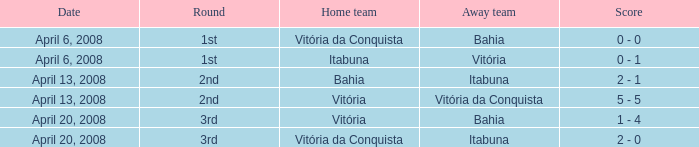Would you be able to parse every entry in this table? {'header': ['Date', 'Round', 'Home team', 'Away team', 'Score'], 'rows': [['April 6, 2008', '1st', 'Vitória da Conquista', 'Bahia', '0 - 0'], ['April 6, 2008', '1st', 'Itabuna', 'Vitória', '0 - 1'], ['April 13, 2008', '2nd', 'Bahia', 'Itabuna', '2 - 1'], ['April 13, 2008', '2nd', 'Vitória', 'Vitória da Conquista', '5 - 5'], ['April 20, 2008', '3rd', 'Vitória', 'Bahia', '1 - 4'], ['April 20, 2008', '3rd', 'Vitória da Conquista', 'Itabuna', '2 - 0']]} On which date was the score 0 - 0? April 6, 2008. 